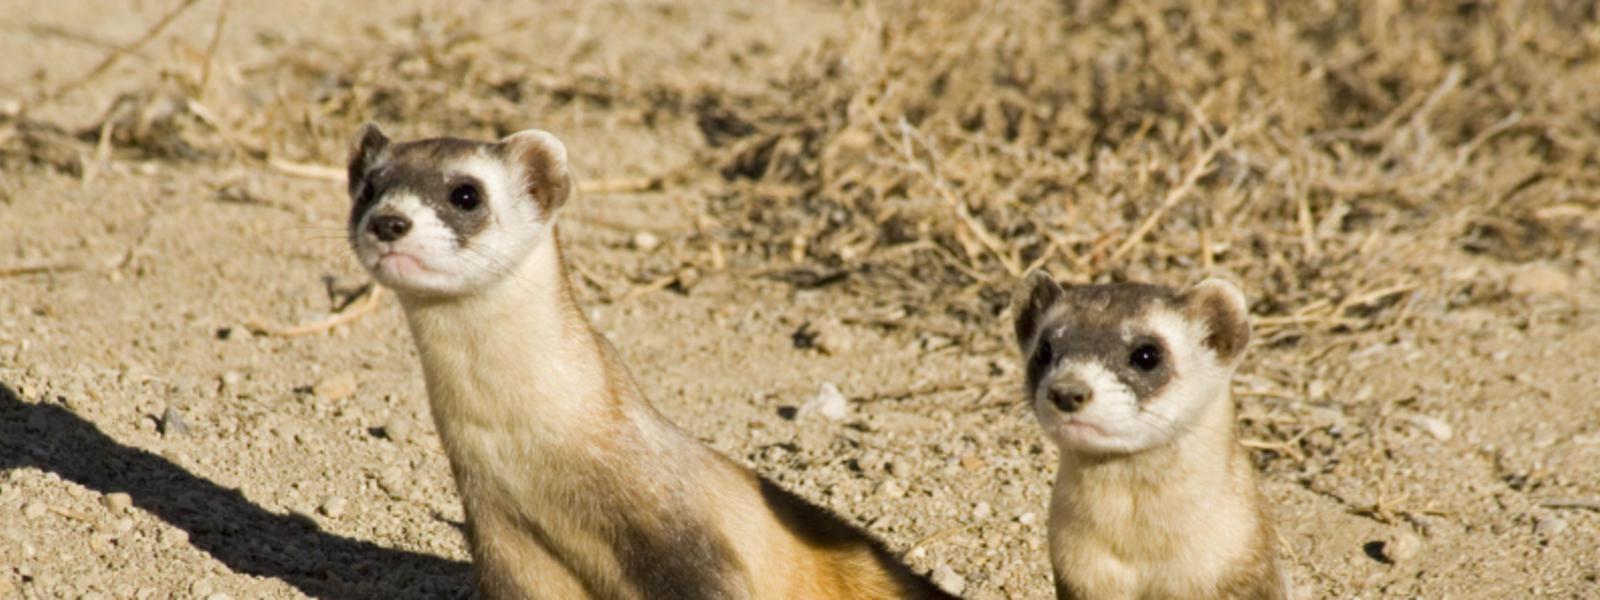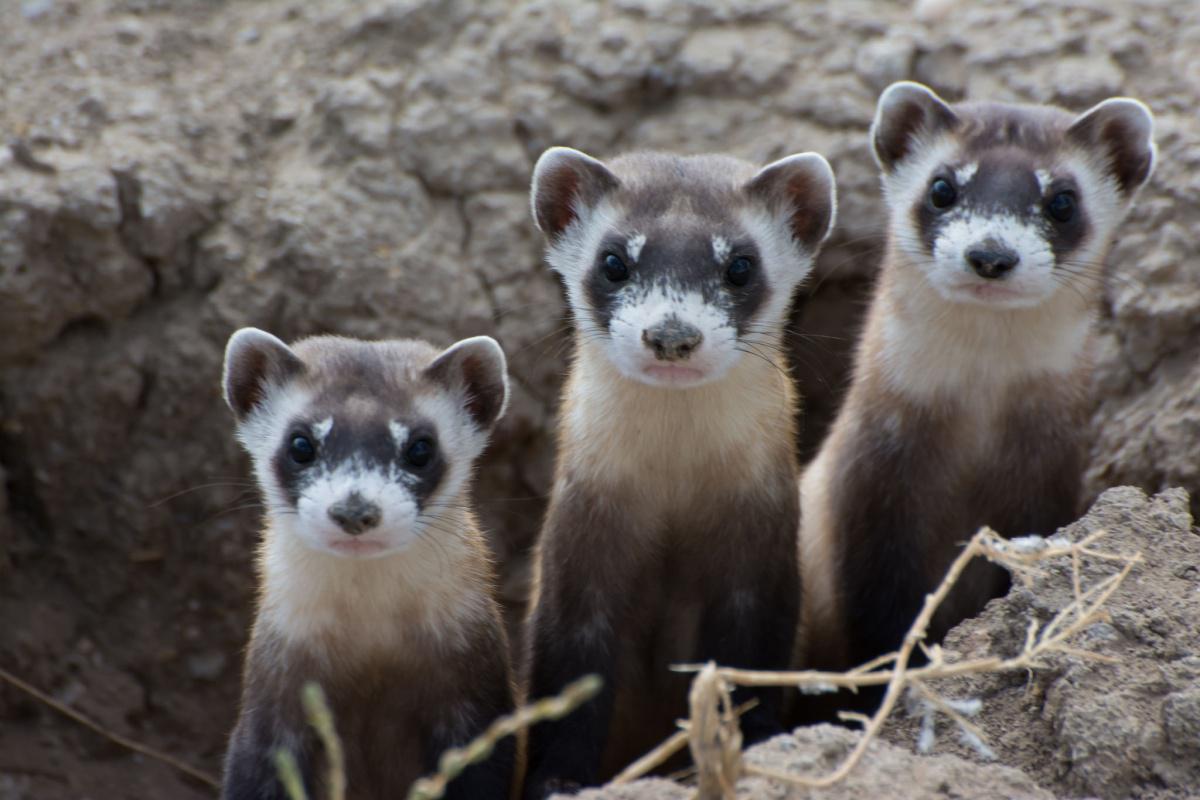The first image is the image on the left, the second image is the image on the right. Evaluate the accuracy of this statement regarding the images: "At least one image has only one weasel.". Is it true? Answer yes or no. No. The first image is the image on the left, the second image is the image on the right. Analyze the images presented: Is the assertion "There are at most four ferrets." valid? Answer yes or no. No. 